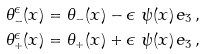<formula> <loc_0><loc_0><loc_500><loc_500>\theta _ { - } ^ { \epsilon } ( x ) & = \theta _ { - } ( x ) - \epsilon \ \psi ( x ) \, e _ { 3 } \, , \\ \theta _ { + } ^ { \epsilon } ( x ) & = \theta _ { + } ( x ) + \epsilon \ \psi ( x ) \, e _ { 3 } \, ,</formula> 